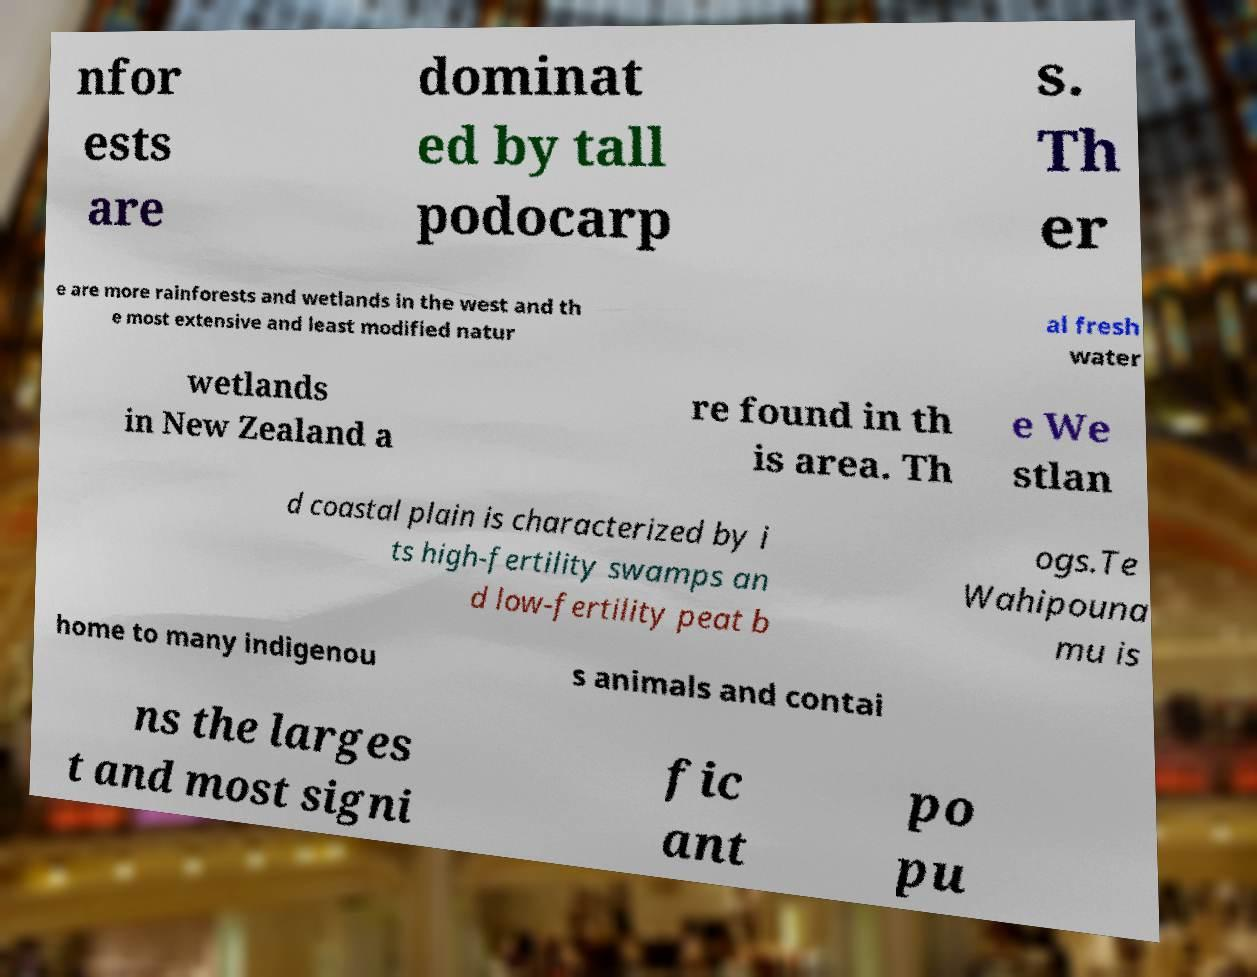Could you extract and type out the text from this image? nfor ests are dominat ed by tall podocarp s. Th er e are more rainforests and wetlands in the west and th e most extensive and least modified natur al fresh water wetlands in New Zealand a re found in th is area. Th e We stlan d coastal plain is characterized by i ts high-fertility swamps an d low-fertility peat b ogs.Te Wahipouna mu is home to many indigenou s animals and contai ns the larges t and most signi fic ant po pu 